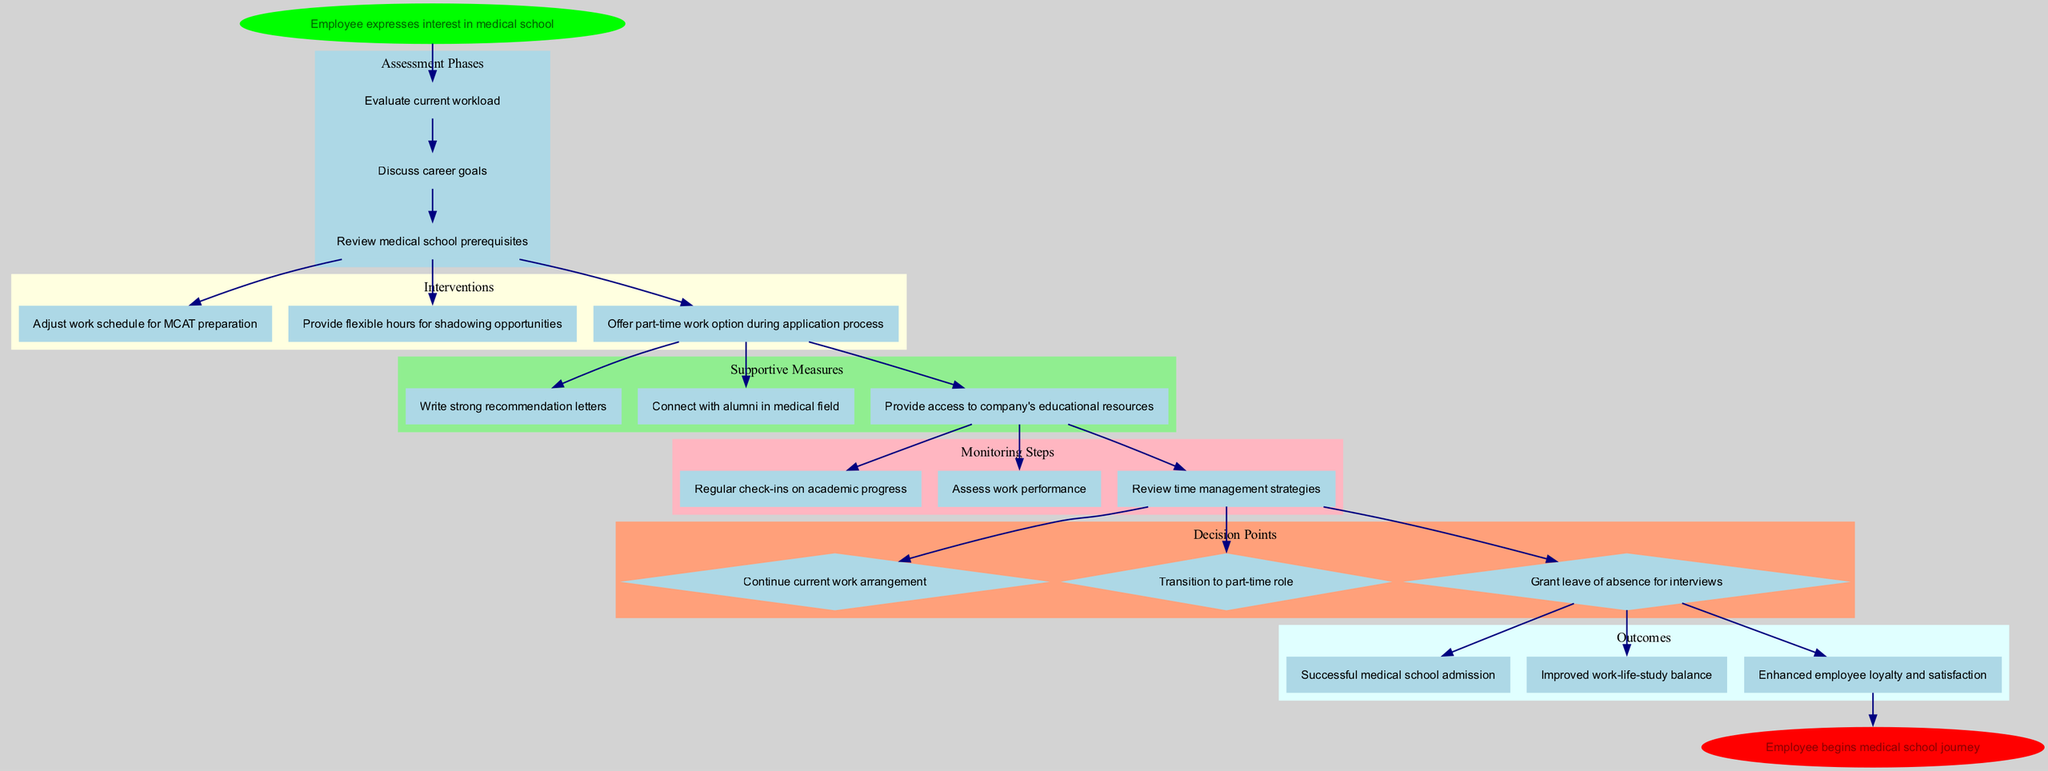What is the starting point of the clinical pathway? The diagram indicates the starting point as "Employee expresses interest in medical school." This is clearly defined at the beginning of the flow structure which sets the context for the entire pathway.
Answer: Employee expresses interest in medical school How many assessment phases are present in the diagram? By reviewing the section labeled "Assessment Phases," we can count the items listed there. There are three phases detailed in that section.
Answer: 3 What type of interventions are provided after the assessment? Following the "Interventions" subgraph in the flow, we can see that they focus primarily on scheduling and workload adjustments. The specific interventions include "Adjust work schedule for MCAT preparation," among others.
Answer: Adjust work schedule for MCAT preparation What is the relationship between supportive measures and monitoring steps? Supportive measures lead directly to monitoring steps, as indicated by the edge connecting the last supportive measure node to the first monitoring step node. This indicates that the supportive measures influence or precede the monitoring steps.
Answer: Supportive measures lead to monitoring steps Which decision point allows for a transition to a part-time role? The decision points include "Transition to part-time role." This indicates that after evaluating progress, the option to transition is presented as a part of the decision-making process.
Answer: Transition to part-time role What is the final outcome of this clinical pathway? The diagram concludes with the endpoint labeled "Employee begins medical school journey," indicating that this is the ultimate outcome derived from following the pathway through the designated steps.
Answer: Employee begins medical school journey How many outcomes are listed in the diagram? By examining the "Outcomes" subgraph, we can count a total of three distinct outcomes listed. This gives insight into the potential results of following the pathway.
Answer: 3 What is the key supportive measure regarding educational resources? Among the supportive measures, there is a specific mention of "Provide access to company's educational resources," highlighting the importance placed on facilitating access to information useful for pursuing medical education.
Answer: Provide access to company's educational resources Which monitoring step focuses on academic progress? The monitoring step labeled "Regular check-ins on academic progress" specifically indicates that there is a focus on the employee's academic progress throughout the pathway.
Answer: Regular check-ins on academic progress 